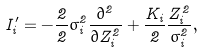<formula> <loc_0><loc_0><loc_500><loc_500>I _ { i } ^ { \prime } = - \frac { 2 } 2 \sigma _ { i } ^ { 2 } \frac { \partial ^ { 2 } } { \partial Z _ { i } ^ { 2 } } + \frac { K _ { i } } 2 \frac { Z _ { i } ^ { 2 } } { \sigma _ { i } ^ { 2 } } ,</formula> 